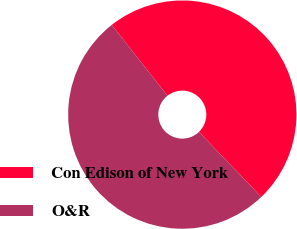<chart> <loc_0><loc_0><loc_500><loc_500><pie_chart><fcel>Con Edison of New York<fcel>O&R<nl><fcel>48.44%<fcel>51.56%<nl></chart> 